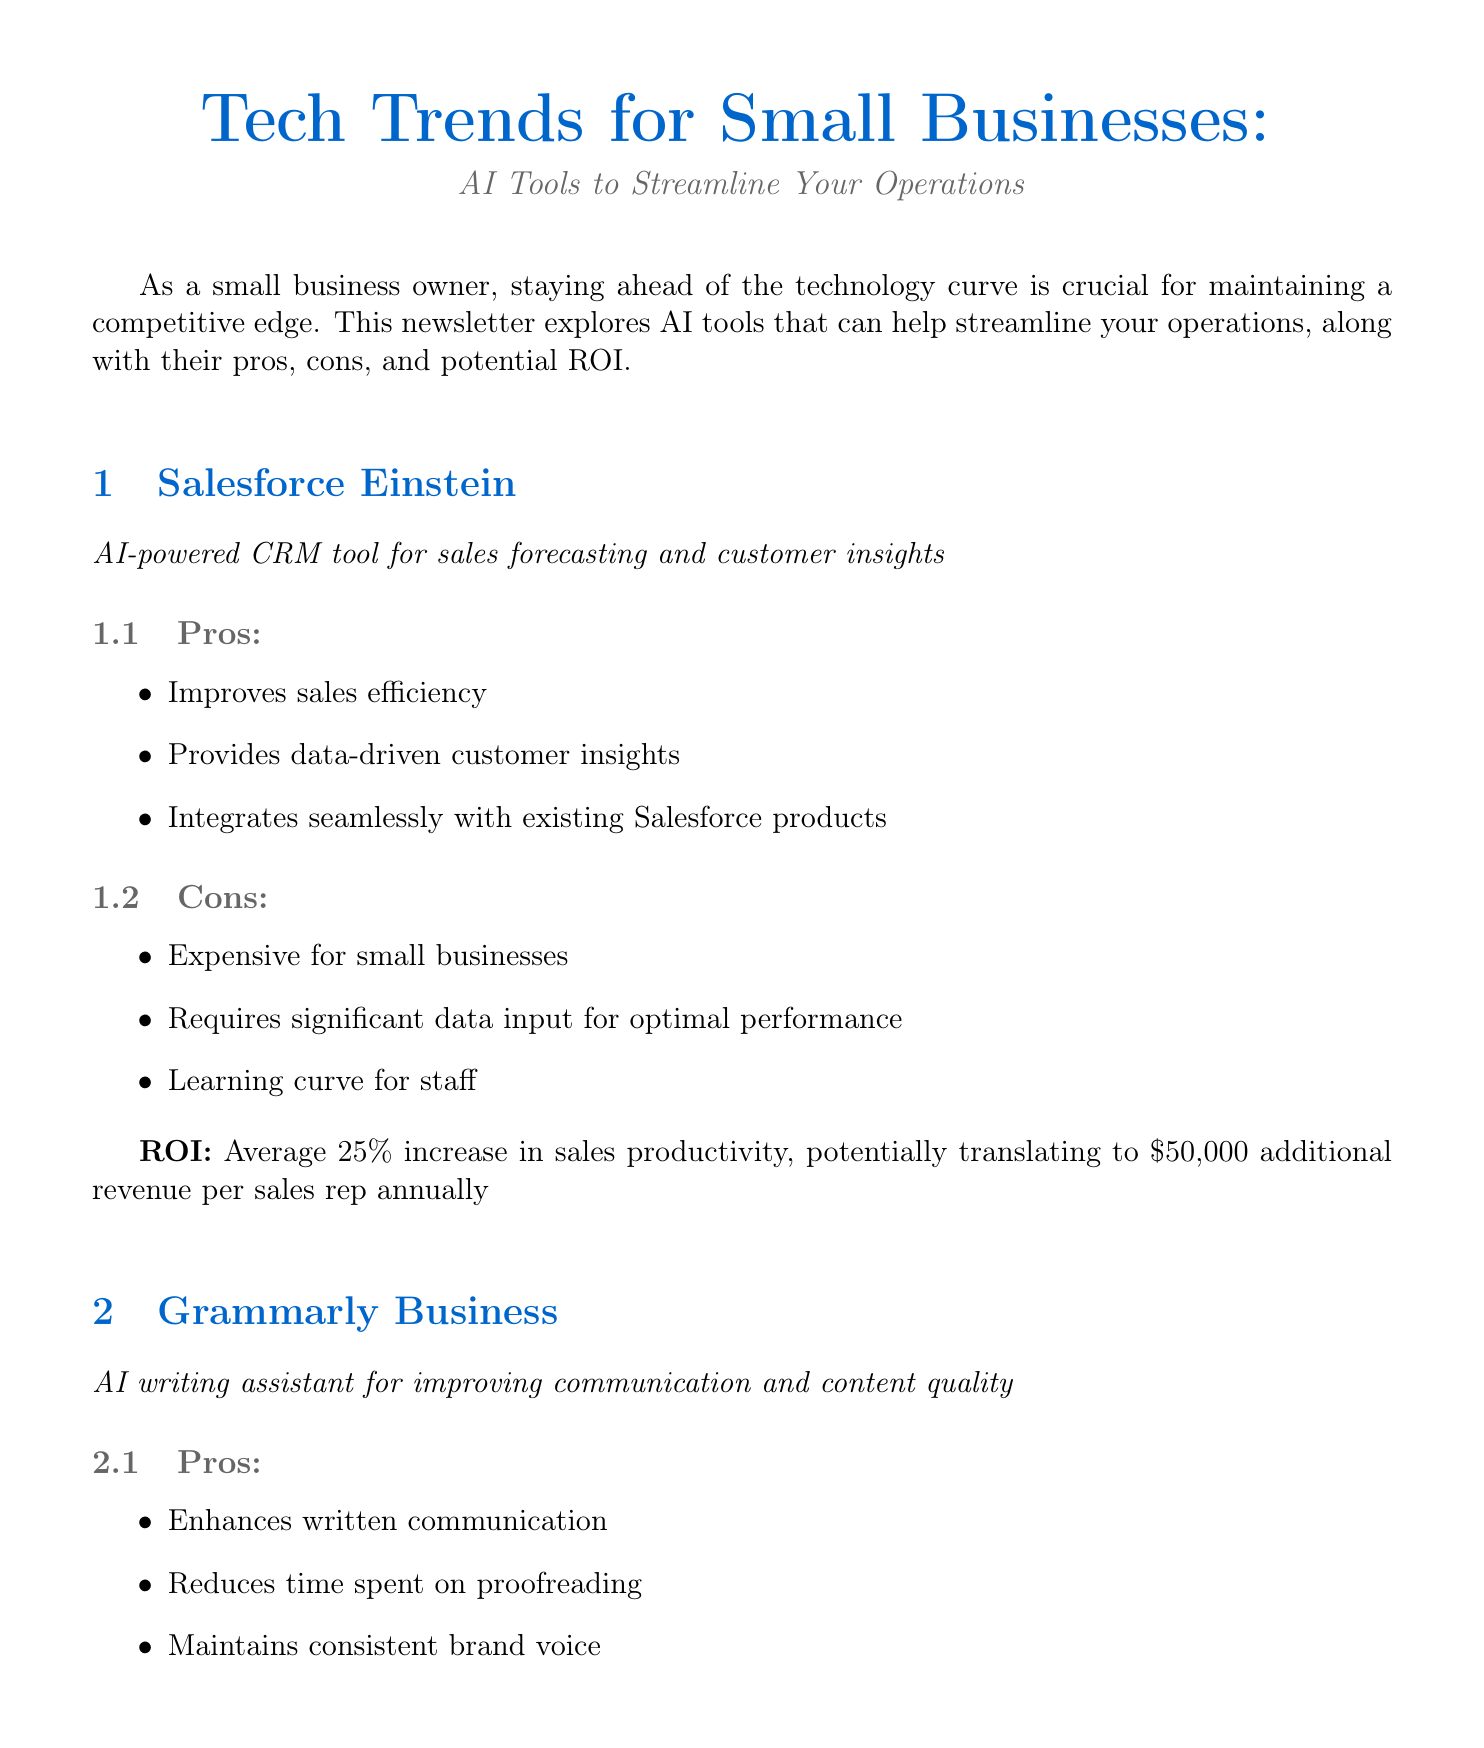What is the newsletter title? The title of the newsletter is explicitly stated at the beginning of the document.
Answer: Tech Trends for Small Businesses: AI Tools to Streamline Your Operations What is a pro of Salesforce Einstein? The document lists the advantages of Salesforce Einstein under the pros section.
Answer: Improves sales efficiency What is a con of Grammarly Business? This con is mentioned in the cons section specific to Grammarly Business in the document.
Answer: Monthly subscription cost What is the potential annual savings from using Zoho Invoice? The ROI calculation section provides a specific figure for potential savings.
Answer: $3,600 What percentage increase in sales productivity does Salesforce Einstein aim for? The ROI calculation section specifically mentions this percentage increase.
Answer: 25% Which tool helps maintain a consistent brand voice? This is a specific benefit mentioned in the pros section for Grammarly Business.
Answer: Grammarly Business What key consideration should be taken when adopting AI tools according to the cybersecurity note? The note emphasizes a crucial action regarding consultation before adopting the tools.
Answer: Consult with your Managed Service Provider (MSP) What is a potential result of using Grammarly Business? This is mentioned in the ROI section of Grammarly Business as a result of its use.
Answer: Approximately $5,000 per employee annually in productivity gains What does Zoho Invoice automate? This specialization is explicitly stated in the pros section related to Zoho Invoice.
Answer: Invoicing process 